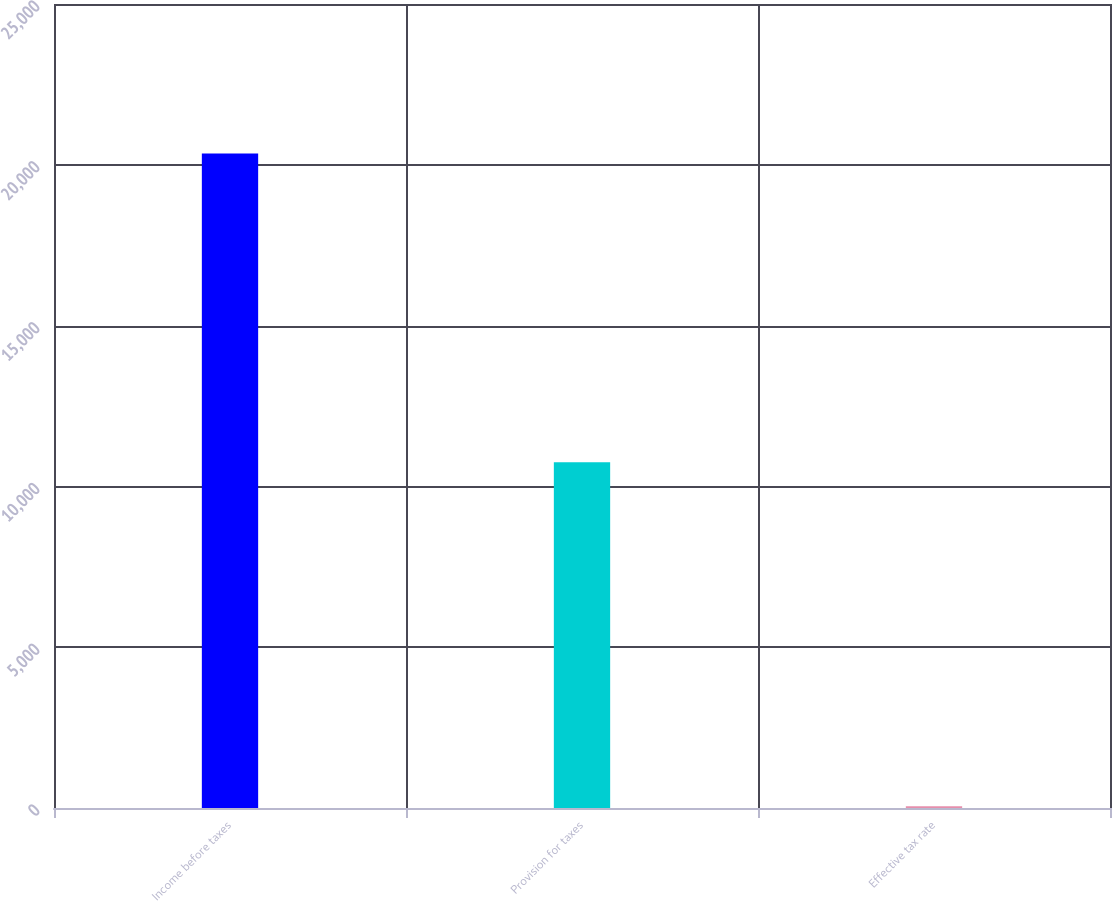<chart> <loc_0><loc_0><loc_500><loc_500><bar_chart><fcel>Income before taxes<fcel>Provision for taxes<fcel>Effective tax rate<nl><fcel>20352<fcel>10751<fcel>52.8<nl></chart> 